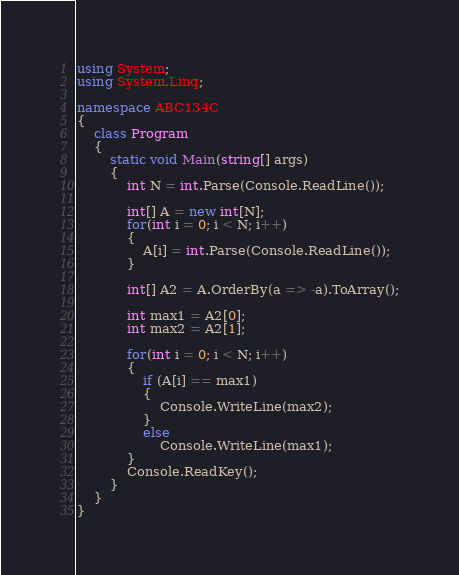<code> <loc_0><loc_0><loc_500><loc_500><_C#_>using System;
using System.Linq;

namespace ABC134C
{
    class Program
    {
        static void Main(string[] args)
        {
            int N = int.Parse(Console.ReadLine());

            int[] A = new int[N];
            for(int i = 0; i < N; i++)
            {
                A[i] = int.Parse(Console.ReadLine());
            }

            int[] A2 = A.OrderBy(a => -a).ToArray();

            int max1 = A2[0];
            int max2 = A2[1];

            for(int i = 0; i < N; i++)
            {
                if (A[i] == max1)
                {
                    Console.WriteLine(max2);
                }
                else
                    Console.WriteLine(max1);
            }
            Console.ReadKey();
        }
    }
}
</code> 